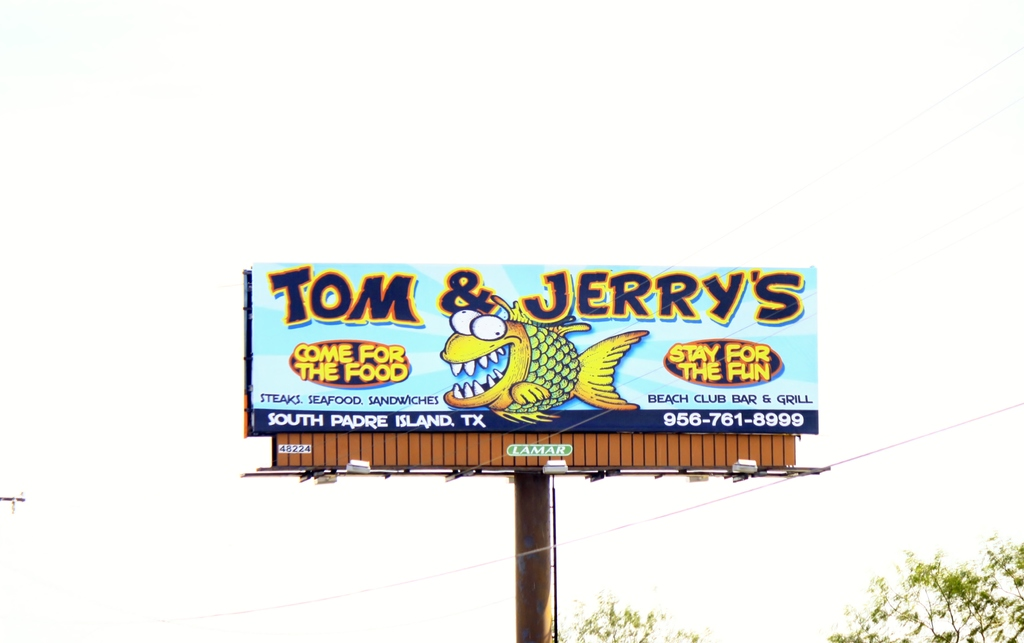What do you think is going on in this snapshot?
 The image features a vibrant billboard for a restaurant named "Tom & Jerry's" located in South Padre Island, Texas. The billboard invites visitors with the catchy slogan "Come for the food, stay for the fun", suggesting a lively and enjoyable dining experience. A cartoon alligator, possibly a mascot, adds a playful touch to the advertisement. The billboard also thoughtfully provides the restaurant's contact number "956-761-8999", making it easy for interested visitors to reach out. 